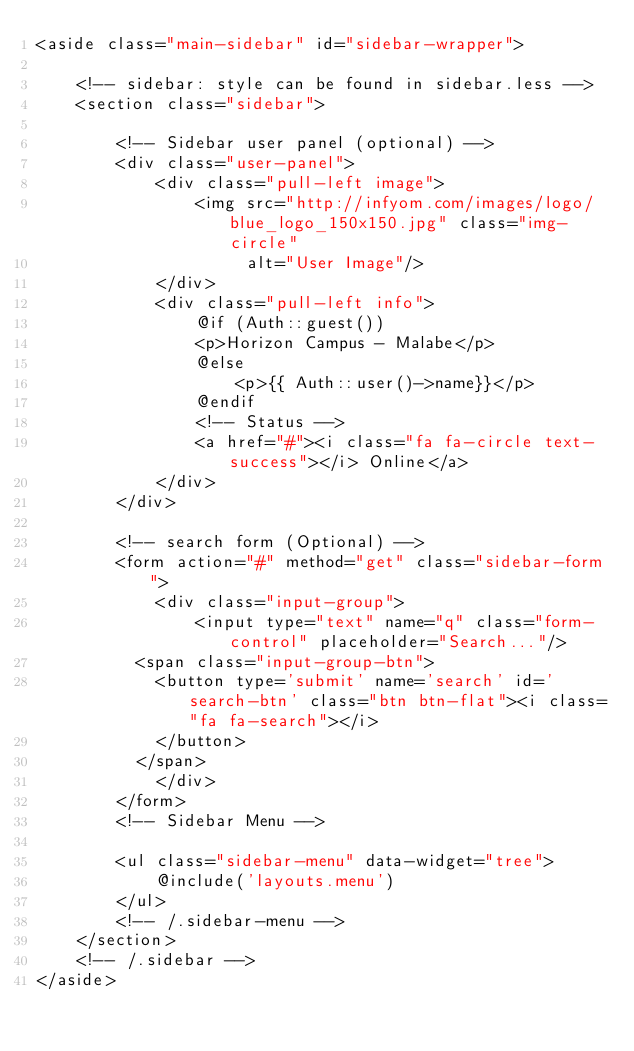Convert code to text. <code><loc_0><loc_0><loc_500><loc_500><_PHP_><aside class="main-sidebar" id="sidebar-wrapper">

    <!-- sidebar: style can be found in sidebar.less -->
    <section class="sidebar">

        <!-- Sidebar user panel (optional) -->
        <div class="user-panel">
            <div class="pull-left image">
                <img src="http://infyom.com/images/logo/blue_logo_150x150.jpg" class="img-circle"
                     alt="User Image"/>
            </div>
            <div class="pull-left info">
                @if (Auth::guest())
                <p>Horizon Campus - Malabe</p>
                @else
                    <p>{{ Auth::user()->name}}</p>
                @endif
                <!-- Status -->
                <a href="#"><i class="fa fa-circle text-success"></i> Online</a>
            </div>
        </div>

        <!-- search form (Optional) -->
        <form action="#" method="get" class="sidebar-form">
            <div class="input-group">
                <input type="text" name="q" class="form-control" placeholder="Search..."/>
          <span class="input-group-btn">
            <button type='submit' name='search' id='search-btn' class="btn btn-flat"><i class="fa fa-search"></i>
            </button>
          </span>
            </div>
        </form>
        <!-- Sidebar Menu -->

        <ul class="sidebar-menu" data-widget="tree">
            @include('layouts.menu')
        </ul>
        <!-- /.sidebar-menu -->
    </section>
    <!-- /.sidebar -->
</aside></code> 